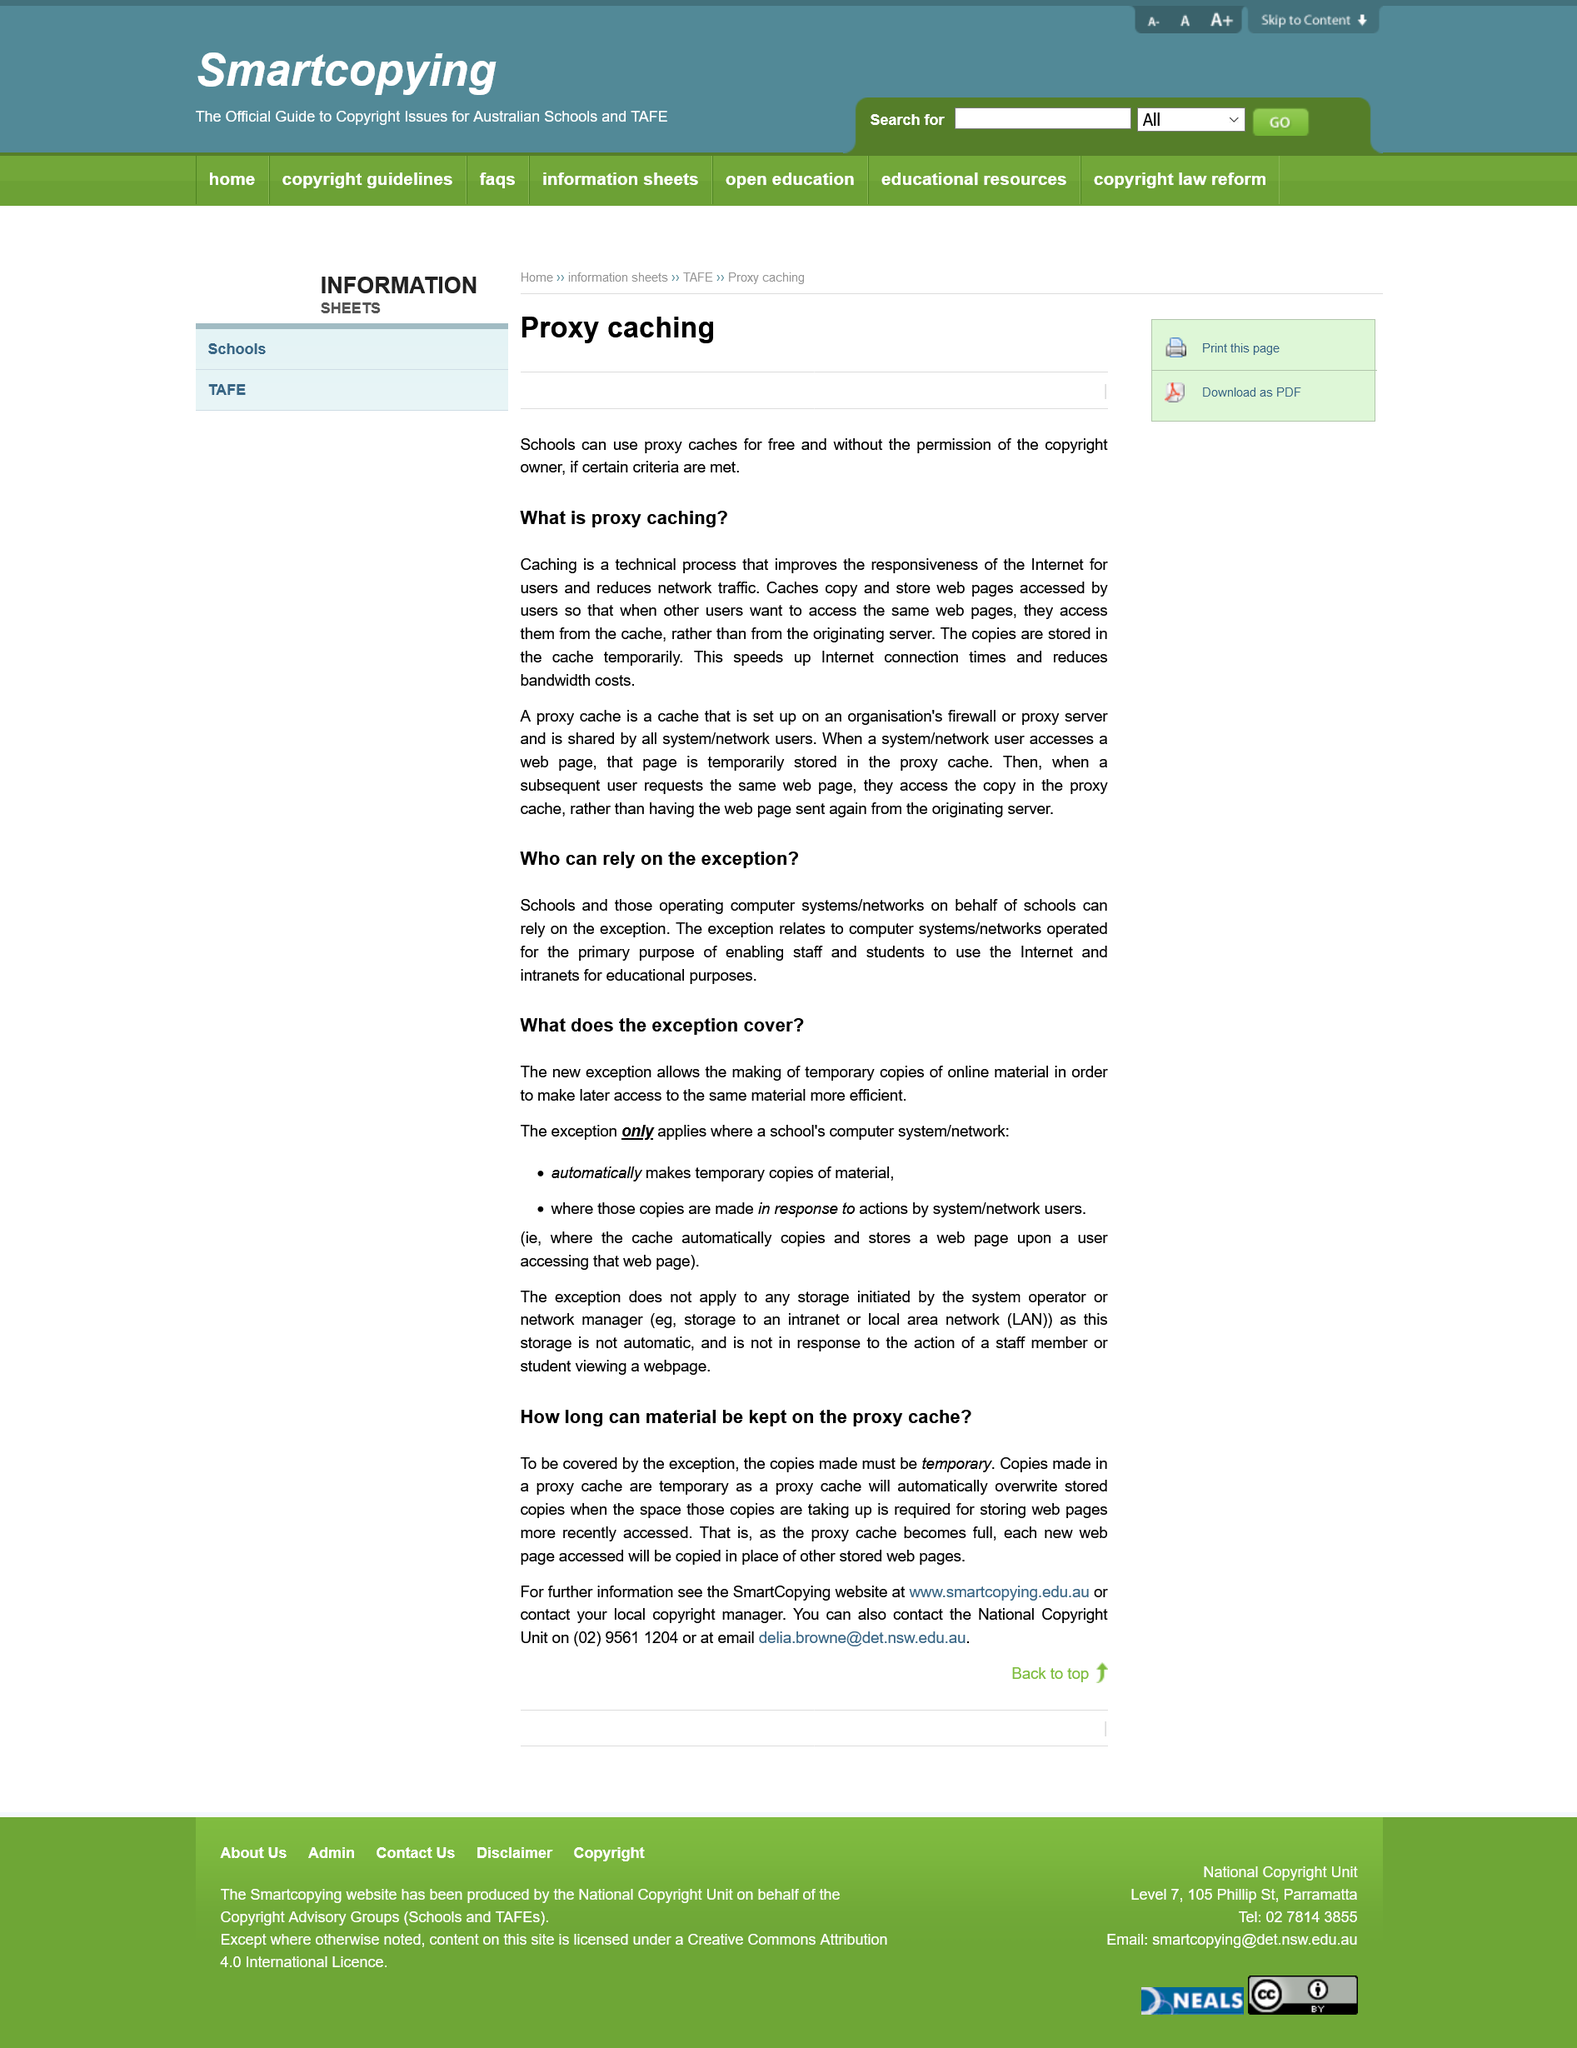Point out several critical features in this image. The title of the second subheading is "What Does the Exception Cover"? Caches are not stored permanently. Proxy caches can be used for free by schools. A cache is a system that copies and stores web pages accessed by users in order to improve the performance of a website. It is the title of the first subheading that reads "Who can rely on this exception?". 